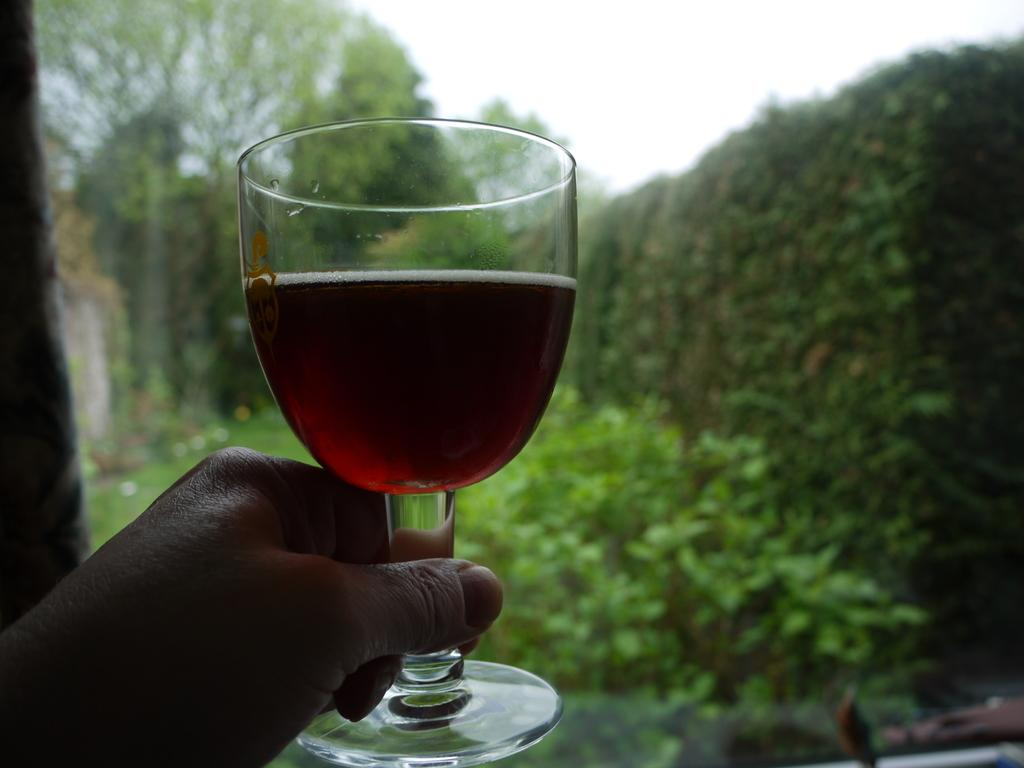What is being held by the person's hand in the image? There is a person's hand holding a glass in the image. What can be seen in the background of the image? There is a group of trees and plants in the background of the image. What part of the natural environment is visible in the image? The sky is visible in the background of the image. What type of rock can be seen in the image? There is no rock present in the image. What toys are being played with in the image? There are no toys present in the image. 